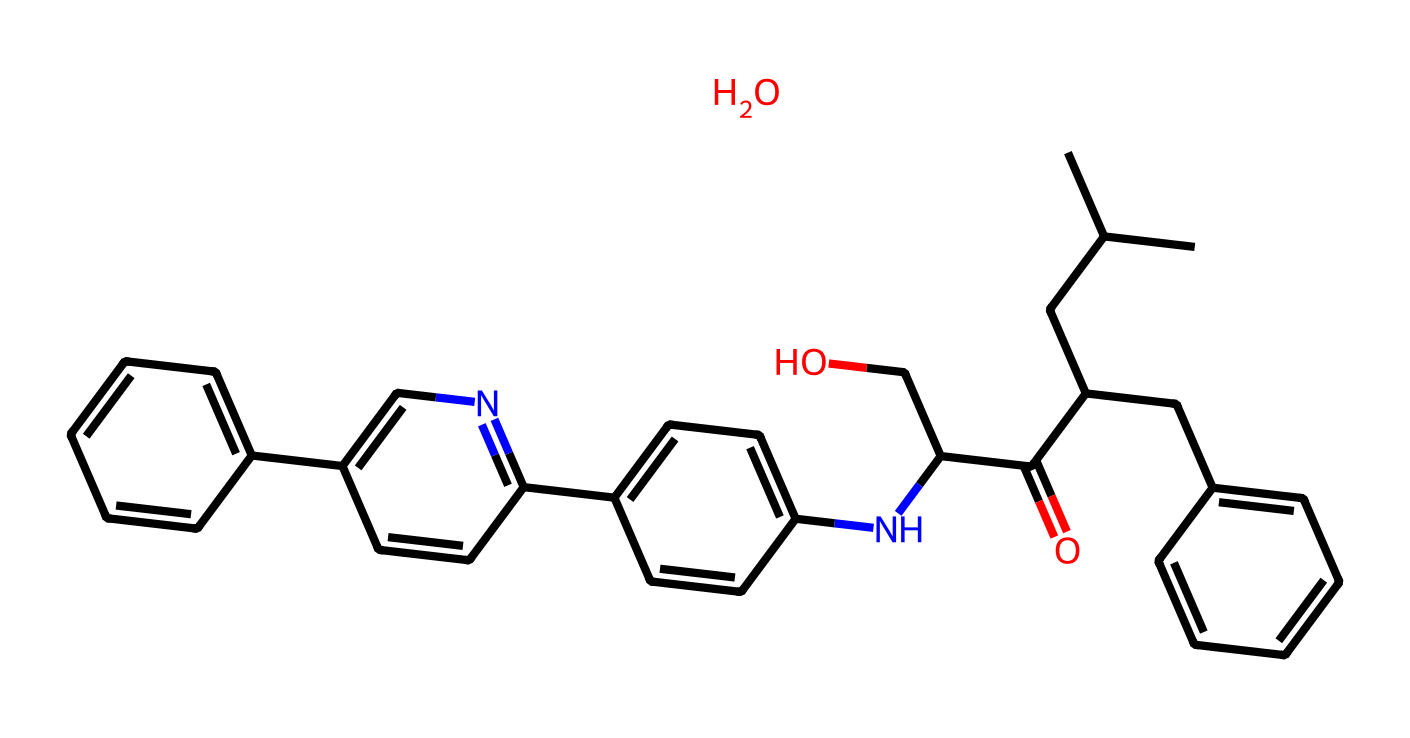What is the base structure of atorvastatin? The base structure of atorvastatin consists of a long carbon chain with a phenolic ring and a substituted nitrogen-containing moiety. The starting point can be identified by the predominant alkyl chain connected to the aromatic rings.
Answer: carbon chain How many rings are present in atorvastatin's structure? Upon analyzing the structure, atorvastatin contains three distinct rings: one benzene ring and two additional aromatic rings that are fused together through nitrogen substitutions. Count each distinct cyclic structure to arrive at the total.
Answer: three What functional group is seen in atorvastatin? The functional group in atorvastatin includes an amine (–NH) linked to a carbonyl group (C=O), which forms part of the amide structure and is critical for its biological activity. Identification involves locating the nitrogen atom connected to the carbon chain.
Answer: amide How many chiral centers are in atorvastatin's molecular structure? A careful examination of the structure shows that atorvastatin features two chiral centers, denoted by the carbon atoms that each have four different substituents attached. Identifying any asymmetric carbons allows us to count chiral centers accurately.
Answer: two What type of drug classification does atorvastatin fall under? Atorvastatin is classified as a statin, a type of drug commonly used to lower cholesterol levels in the blood. This classification stems from its action on HMG-CoA reductase, crucial for cholesterol biosynthesis.
Answer: statin What is the total number of oxygen atoms in the atorvastatin structure? By inspecting the molecular composition, there are three oxygen atoms present in atorvastatin. These can be located in both the functional groups and hydroxyl functionalities connected within the structure.
Answer: three 